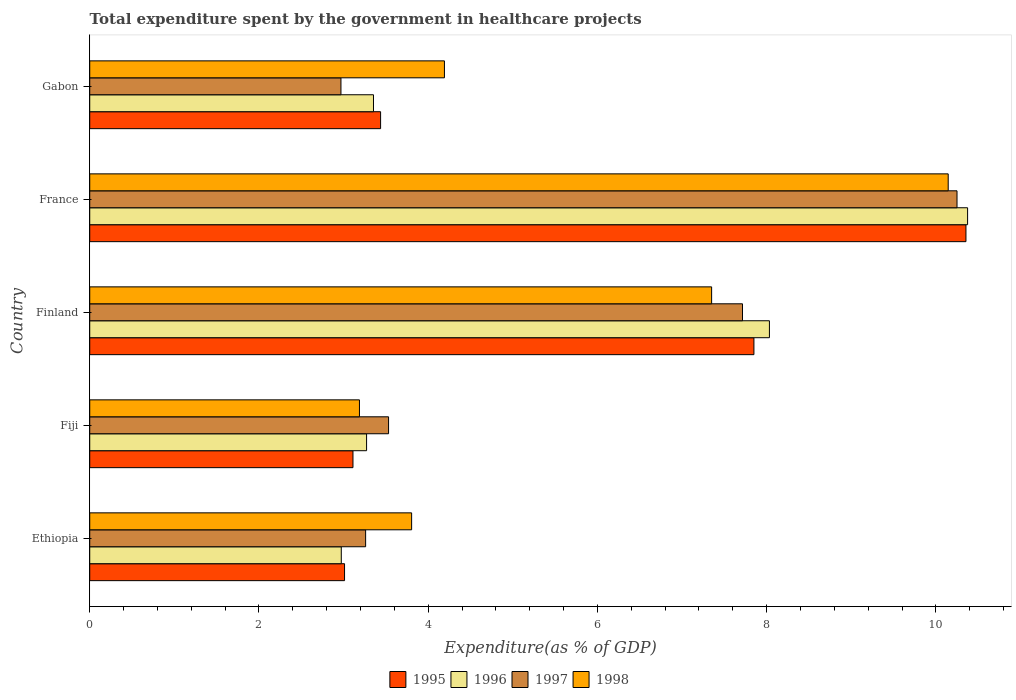How many different coloured bars are there?
Ensure brevity in your answer.  4. How many groups of bars are there?
Your response must be concise. 5. How many bars are there on the 1st tick from the top?
Offer a terse response. 4. How many bars are there on the 2nd tick from the bottom?
Your answer should be very brief. 4. What is the label of the 1st group of bars from the top?
Ensure brevity in your answer.  Gabon. In how many cases, is the number of bars for a given country not equal to the number of legend labels?
Provide a short and direct response. 0. What is the total expenditure spent by the government in healthcare projects in 1995 in Fiji?
Provide a short and direct response. 3.11. Across all countries, what is the maximum total expenditure spent by the government in healthcare projects in 1997?
Give a very brief answer. 10.25. Across all countries, what is the minimum total expenditure spent by the government in healthcare projects in 1995?
Provide a short and direct response. 3.01. In which country was the total expenditure spent by the government in healthcare projects in 1998 maximum?
Your answer should be very brief. France. In which country was the total expenditure spent by the government in healthcare projects in 1998 minimum?
Your answer should be compact. Fiji. What is the total total expenditure spent by the government in healthcare projects in 1998 in the graph?
Provide a short and direct response. 28.68. What is the difference between the total expenditure spent by the government in healthcare projects in 1998 in Finland and that in France?
Make the answer very short. -2.8. What is the difference between the total expenditure spent by the government in healthcare projects in 1997 in France and the total expenditure spent by the government in healthcare projects in 1998 in Finland?
Provide a short and direct response. 2.9. What is the average total expenditure spent by the government in healthcare projects in 1995 per country?
Make the answer very short. 5.55. What is the difference between the total expenditure spent by the government in healthcare projects in 1995 and total expenditure spent by the government in healthcare projects in 1997 in Finland?
Give a very brief answer. 0.14. In how many countries, is the total expenditure spent by the government in healthcare projects in 1997 greater than 6.4 %?
Give a very brief answer. 2. What is the ratio of the total expenditure spent by the government in healthcare projects in 1998 in Finland to that in Gabon?
Keep it short and to the point. 1.75. Is the total expenditure spent by the government in healthcare projects in 1997 in Ethiopia less than that in Fiji?
Keep it short and to the point. Yes. What is the difference between the highest and the second highest total expenditure spent by the government in healthcare projects in 1998?
Keep it short and to the point. 2.8. What is the difference between the highest and the lowest total expenditure spent by the government in healthcare projects in 1998?
Your answer should be very brief. 6.96. What does the 4th bar from the bottom in Gabon represents?
Provide a succinct answer. 1998. How many bars are there?
Provide a succinct answer. 20. Are all the bars in the graph horizontal?
Keep it short and to the point. Yes. Are the values on the major ticks of X-axis written in scientific E-notation?
Keep it short and to the point. No. Where does the legend appear in the graph?
Your answer should be compact. Bottom center. What is the title of the graph?
Your answer should be very brief. Total expenditure spent by the government in healthcare projects. Does "1984" appear as one of the legend labels in the graph?
Keep it short and to the point. No. What is the label or title of the X-axis?
Provide a short and direct response. Expenditure(as % of GDP). What is the Expenditure(as % of GDP) of 1995 in Ethiopia?
Keep it short and to the point. 3.01. What is the Expenditure(as % of GDP) in 1996 in Ethiopia?
Your response must be concise. 2.97. What is the Expenditure(as % of GDP) in 1997 in Ethiopia?
Ensure brevity in your answer.  3.26. What is the Expenditure(as % of GDP) of 1998 in Ethiopia?
Your answer should be very brief. 3.8. What is the Expenditure(as % of GDP) of 1995 in Fiji?
Offer a very short reply. 3.11. What is the Expenditure(as % of GDP) of 1996 in Fiji?
Provide a succinct answer. 3.27. What is the Expenditure(as % of GDP) of 1997 in Fiji?
Ensure brevity in your answer.  3.53. What is the Expenditure(as % of GDP) of 1998 in Fiji?
Make the answer very short. 3.19. What is the Expenditure(as % of GDP) in 1995 in Finland?
Your response must be concise. 7.85. What is the Expenditure(as % of GDP) of 1996 in Finland?
Your response must be concise. 8.03. What is the Expenditure(as % of GDP) of 1997 in Finland?
Make the answer very short. 7.71. What is the Expenditure(as % of GDP) of 1998 in Finland?
Keep it short and to the point. 7.35. What is the Expenditure(as % of GDP) in 1995 in France?
Ensure brevity in your answer.  10.36. What is the Expenditure(as % of GDP) of 1996 in France?
Give a very brief answer. 10.38. What is the Expenditure(as % of GDP) in 1997 in France?
Your answer should be compact. 10.25. What is the Expenditure(as % of GDP) of 1998 in France?
Your answer should be very brief. 10.15. What is the Expenditure(as % of GDP) in 1995 in Gabon?
Provide a short and direct response. 3.44. What is the Expenditure(as % of GDP) of 1996 in Gabon?
Your answer should be compact. 3.35. What is the Expenditure(as % of GDP) in 1997 in Gabon?
Provide a short and direct response. 2.97. What is the Expenditure(as % of GDP) of 1998 in Gabon?
Offer a terse response. 4.19. Across all countries, what is the maximum Expenditure(as % of GDP) in 1995?
Your answer should be compact. 10.36. Across all countries, what is the maximum Expenditure(as % of GDP) in 1996?
Your answer should be very brief. 10.38. Across all countries, what is the maximum Expenditure(as % of GDP) in 1997?
Offer a terse response. 10.25. Across all countries, what is the maximum Expenditure(as % of GDP) in 1998?
Your answer should be very brief. 10.15. Across all countries, what is the minimum Expenditure(as % of GDP) in 1995?
Make the answer very short. 3.01. Across all countries, what is the minimum Expenditure(as % of GDP) in 1996?
Your answer should be compact. 2.97. Across all countries, what is the minimum Expenditure(as % of GDP) of 1997?
Offer a terse response. 2.97. Across all countries, what is the minimum Expenditure(as % of GDP) in 1998?
Provide a short and direct response. 3.19. What is the total Expenditure(as % of GDP) of 1995 in the graph?
Your response must be concise. 27.77. What is the total Expenditure(as % of GDP) in 1996 in the graph?
Provide a short and direct response. 28.01. What is the total Expenditure(as % of GDP) in 1997 in the graph?
Make the answer very short. 27.73. What is the total Expenditure(as % of GDP) of 1998 in the graph?
Offer a terse response. 28.68. What is the difference between the Expenditure(as % of GDP) in 1995 in Ethiopia and that in Fiji?
Provide a short and direct response. -0.1. What is the difference between the Expenditure(as % of GDP) of 1996 in Ethiopia and that in Fiji?
Offer a very short reply. -0.3. What is the difference between the Expenditure(as % of GDP) of 1997 in Ethiopia and that in Fiji?
Your answer should be compact. -0.27. What is the difference between the Expenditure(as % of GDP) of 1998 in Ethiopia and that in Fiji?
Ensure brevity in your answer.  0.62. What is the difference between the Expenditure(as % of GDP) of 1995 in Ethiopia and that in Finland?
Your answer should be very brief. -4.84. What is the difference between the Expenditure(as % of GDP) in 1996 in Ethiopia and that in Finland?
Your answer should be very brief. -5.06. What is the difference between the Expenditure(as % of GDP) of 1997 in Ethiopia and that in Finland?
Ensure brevity in your answer.  -4.45. What is the difference between the Expenditure(as % of GDP) of 1998 in Ethiopia and that in Finland?
Provide a succinct answer. -3.55. What is the difference between the Expenditure(as % of GDP) of 1995 in Ethiopia and that in France?
Your answer should be very brief. -7.34. What is the difference between the Expenditure(as % of GDP) of 1996 in Ethiopia and that in France?
Provide a short and direct response. -7.4. What is the difference between the Expenditure(as % of GDP) of 1997 in Ethiopia and that in France?
Your answer should be compact. -6.99. What is the difference between the Expenditure(as % of GDP) in 1998 in Ethiopia and that in France?
Ensure brevity in your answer.  -6.34. What is the difference between the Expenditure(as % of GDP) in 1995 in Ethiopia and that in Gabon?
Your response must be concise. -0.43. What is the difference between the Expenditure(as % of GDP) in 1996 in Ethiopia and that in Gabon?
Make the answer very short. -0.38. What is the difference between the Expenditure(as % of GDP) in 1997 in Ethiopia and that in Gabon?
Offer a very short reply. 0.29. What is the difference between the Expenditure(as % of GDP) in 1998 in Ethiopia and that in Gabon?
Your answer should be very brief. -0.39. What is the difference between the Expenditure(as % of GDP) of 1995 in Fiji and that in Finland?
Your response must be concise. -4.74. What is the difference between the Expenditure(as % of GDP) in 1996 in Fiji and that in Finland?
Keep it short and to the point. -4.76. What is the difference between the Expenditure(as % of GDP) of 1997 in Fiji and that in Finland?
Provide a succinct answer. -4.18. What is the difference between the Expenditure(as % of GDP) of 1998 in Fiji and that in Finland?
Your answer should be very brief. -4.16. What is the difference between the Expenditure(as % of GDP) in 1995 in Fiji and that in France?
Provide a short and direct response. -7.24. What is the difference between the Expenditure(as % of GDP) in 1996 in Fiji and that in France?
Your answer should be very brief. -7.1. What is the difference between the Expenditure(as % of GDP) of 1997 in Fiji and that in France?
Offer a terse response. -6.72. What is the difference between the Expenditure(as % of GDP) of 1998 in Fiji and that in France?
Make the answer very short. -6.96. What is the difference between the Expenditure(as % of GDP) in 1995 in Fiji and that in Gabon?
Provide a short and direct response. -0.33. What is the difference between the Expenditure(as % of GDP) of 1996 in Fiji and that in Gabon?
Keep it short and to the point. -0.08. What is the difference between the Expenditure(as % of GDP) in 1997 in Fiji and that in Gabon?
Offer a very short reply. 0.56. What is the difference between the Expenditure(as % of GDP) of 1998 in Fiji and that in Gabon?
Make the answer very short. -1. What is the difference between the Expenditure(as % of GDP) of 1995 in Finland and that in France?
Provide a short and direct response. -2.51. What is the difference between the Expenditure(as % of GDP) in 1996 in Finland and that in France?
Make the answer very short. -2.34. What is the difference between the Expenditure(as % of GDP) in 1997 in Finland and that in France?
Your response must be concise. -2.54. What is the difference between the Expenditure(as % of GDP) of 1998 in Finland and that in France?
Your response must be concise. -2.8. What is the difference between the Expenditure(as % of GDP) of 1995 in Finland and that in Gabon?
Offer a very short reply. 4.41. What is the difference between the Expenditure(as % of GDP) in 1996 in Finland and that in Gabon?
Offer a terse response. 4.68. What is the difference between the Expenditure(as % of GDP) of 1997 in Finland and that in Gabon?
Provide a short and direct response. 4.75. What is the difference between the Expenditure(as % of GDP) in 1998 in Finland and that in Gabon?
Provide a short and direct response. 3.16. What is the difference between the Expenditure(as % of GDP) of 1995 in France and that in Gabon?
Make the answer very short. 6.92. What is the difference between the Expenditure(as % of GDP) in 1996 in France and that in Gabon?
Ensure brevity in your answer.  7.02. What is the difference between the Expenditure(as % of GDP) of 1997 in France and that in Gabon?
Your answer should be very brief. 7.28. What is the difference between the Expenditure(as % of GDP) of 1998 in France and that in Gabon?
Make the answer very short. 5.95. What is the difference between the Expenditure(as % of GDP) in 1995 in Ethiopia and the Expenditure(as % of GDP) in 1996 in Fiji?
Ensure brevity in your answer.  -0.26. What is the difference between the Expenditure(as % of GDP) of 1995 in Ethiopia and the Expenditure(as % of GDP) of 1997 in Fiji?
Provide a succinct answer. -0.52. What is the difference between the Expenditure(as % of GDP) of 1995 in Ethiopia and the Expenditure(as % of GDP) of 1998 in Fiji?
Give a very brief answer. -0.18. What is the difference between the Expenditure(as % of GDP) of 1996 in Ethiopia and the Expenditure(as % of GDP) of 1997 in Fiji?
Make the answer very short. -0.56. What is the difference between the Expenditure(as % of GDP) in 1996 in Ethiopia and the Expenditure(as % of GDP) in 1998 in Fiji?
Make the answer very short. -0.21. What is the difference between the Expenditure(as % of GDP) in 1997 in Ethiopia and the Expenditure(as % of GDP) in 1998 in Fiji?
Give a very brief answer. 0.07. What is the difference between the Expenditure(as % of GDP) in 1995 in Ethiopia and the Expenditure(as % of GDP) in 1996 in Finland?
Offer a very short reply. -5.02. What is the difference between the Expenditure(as % of GDP) in 1995 in Ethiopia and the Expenditure(as % of GDP) in 1997 in Finland?
Keep it short and to the point. -4.7. What is the difference between the Expenditure(as % of GDP) in 1995 in Ethiopia and the Expenditure(as % of GDP) in 1998 in Finland?
Provide a short and direct response. -4.34. What is the difference between the Expenditure(as % of GDP) of 1996 in Ethiopia and the Expenditure(as % of GDP) of 1997 in Finland?
Provide a short and direct response. -4.74. What is the difference between the Expenditure(as % of GDP) of 1996 in Ethiopia and the Expenditure(as % of GDP) of 1998 in Finland?
Ensure brevity in your answer.  -4.38. What is the difference between the Expenditure(as % of GDP) of 1997 in Ethiopia and the Expenditure(as % of GDP) of 1998 in Finland?
Ensure brevity in your answer.  -4.09. What is the difference between the Expenditure(as % of GDP) in 1995 in Ethiopia and the Expenditure(as % of GDP) in 1996 in France?
Offer a very short reply. -7.36. What is the difference between the Expenditure(as % of GDP) of 1995 in Ethiopia and the Expenditure(as % of GDP) of 1997 in France?
Your answer should be very brief. -7.24. What is the difference between the Expenditure(as % of GDP) of 1995 in Ethiopia and the Expenditure(as % of GDP) of 1998 in France?
Keep it short and to the point. -7.13. What is the difference between the Expenditure(as % of GDP) in 1996 in Ethiopia and the Expenditure(as % of GDP) in 1997 in France?
Offer a very short reply. -7.28. What is the difference between the Expenditure(as % of GDP) in 1996 in Ethiopia and the Expenditure(as % of GDP) in 1998 in France?
Keep it short and to the point. -7.17. What is the difference between the Expenditure(as % of GDP) in 1997 in Ethiopia and the Expenditure(as % of GDP) in 1998 in France?
Keep it short and to the point. -6.89. What is the difference between the Expenditure(as % of GDP) of 1995 in Ethiopia and the Expenditure(as % of GDP) of 1996 in Gabon?
Your response must be concise. -0.34. What is the difference between the Expenditure(as % of GDP) in 1995 in Ethiopia and the Expenditure(as % of GDP) in 1997 in Gabon?
Ensure brevity in your answer.  0.04. What is the difference between the Expenditure(as % of GDP) of 1995 in Ethiopia and the Expenditure(as % of GDP) of 1998 in Gabon?
Provide a succinct answer. -1.18. What is the difference between the Expenditure(as % of GDP) in 1996 in Ethiopia and the Expenditure(as % of GDP) in 1997 in Gabon?
Keep it short and to the point. 0. What is the difference between the Expenditure(as % of GDP) in 1996 in Ethiopia and the Expenditure(as % of GDP) in 1998 in Gabon?
Ensure brevity in your answer.  -1.22. What is the difference between the Expenditure(as % of GDP) in 1997 in Ethiopia and the Expenditure(as % of GDP) in 1998 in Gabon?
Your answer should be very brief. -0.93. What is the difference between the Expenditure(as % of GDP) in 1995 in Fiji and the Expenditure(as % of GDP) in 1996 in Finland?
Make the answer very short. -4.92. What is the difference between the Expenditure(as % of GDP) of 1995 in Fiji and the Expenditure(as % of GDP) of 1997 in Finland?
Provide a succinct answer. -4.6. What is the difference between the Expenditure(as % of GDP) in 1995 in Fiji and the Expenditure(as % of GDP) in 1998 in Finland?
Offer a very short reply. -4.24. What is the difference between the Expenditure(as % of GDP) of 1996 in Fiji and the Expenditure(as % of GDP) of 1997 in Finland?
Provide a short and direct response. -4.44. What is the difference between the Expenditure(as % of GDP) in 1996 in Fiji and the Expenditure(as % of GDP) in 1998 in Finland?
Provide a short and direct response. -4.08. What is the difference between the Expenditure(as % of GDP) of 1997 in Fiji and the Expenditure(as % of GDP) of 1998 in Finland?
Your answer should be very brief. -3.82. What is the difference between the Expenditure(as % of GDP) of 1995 in Fiji and the Expenditure(as % of GDP) of 1996 in France?
Give a very brief answer. -7.26. What is the difference between the Expenditure(as % of GDP) in 1995 in Fiji and the Expenditure(as % of GDP) in 1997 in France?
Offer a terse response. -7.14. What is the difference between the Expenditure(as % of GDP) in 1995 in Fiji and the Expenditure(as % of GDP) in 1998 in France?
Offer a very short reply. -7.04. What is the difference between the Expenditure(as % of GDP) of 1996 in Fiji and the Expenditure(as % of GDP) of 1997 in France?
Offer a terse response. -6.98. What is the difference between the Expenditure(as % of GDP) in 1996 in Fiji and the Expenditure(as % of GDP) in 1998 in France?
Keep it short and to the point. -6.87. What is the difference between the Expenditure(as % of GDP) of 1997 in Fiji and the Expenditure(as % of GDP) of 1998 in France?
Your answer should be compact. -6.61. What is the difference between the Expenditure(as % of GDP) in 1995 in Fiji and the Expenditure(as % of GDP) in 1996 in Gabon?
Ensure brevity in your answer.  -0.24. What is the difference between the Expenditure(as % of GDP) in 1995 in Fiji and the Expenditure(as % of GDP) in 1997 in Gabon?
Keep it short and to the point. 0.14. What is the difference between the Expenditure(as % of GDP) of 1995 in Fiji and the Expenditure(as % of GDP) of 1998 in Gabon?
Provide a succinct answer. -1.08. What is the difference between the Expenditure(as % of GDP) of 1996 in Fiji and the Expenditure(as % of GDP) of 1997 in Gabon?
Make the answer very short. 0.3. What is the difference between the Expenditure(as % of GDP) of 1996 in Fiji and the Expenditure(as % of GDP) of 1998 in Gabon?
Ensure brevity in your answer.  -0.92. What is the difference between the Expenditure(as % of GDP) of 1997 in Fiji and the Expenditure(as % of GDP) of 1998 in Gabon?
Your response must be concise. -0.66. What is the difference between the Expenditure(as % of GDP) of 1995 in Finland and the Expenditure(as % of GDP) of 1996 in France?
Offer a very short reply. -2.53. What is the difference between the Expenditure(as % of GDP) of 1995 in Finland and the Expenditure(as % of GDP) of 1997 in France?
Give a very brief answer. -2.4. What is the difference between the Expenditure(as % of GDP) in 1995 in Finland and the Expenditure(as % of GDP) in 1998 in France?
Ensure brevity in your answer.  -2.3. What is the difference between the Expenditure(as % of GDP) of 1996 in Finland and the Expenditure(as % of GDP) of 1997 in France?
Ensure brevity in your answer.  -2.22. What is the difference between the Expenditure(as % of GDP) of 1996 in Finland and the Expenditure(as % of GDP) of 1998 in France?
Provide a short and direct response. -2.11. What is the difference between the Expenditure(as % of GDP) of 1997 in Finland and the Expenditure(as % of GDP) of 1998 in France?
Provide a short and direct response. -2.43. What is the difference between the Expenditure(as % of GDP) in 1995 in Finland and the Expenditure(as % of GDP) in 1996 in Gabon?
Provide a short and direct response. 4.5. What is the difference between the Expenditure(as % of GDP) in 1995 in Finland and the Expenditure(as % of GDP) in 1997 in Gabon?
Your answer should be compact. 4.88. What is the difference between the Expenditure(as % of GDP) of 1995 in Finland and the Expenditure(as % of GDP) of 1998 in Gabon?
Ensure brevity in your answer.  3.66. What is the difference between the Expenditure(as % of GDP) in 1996 in Finland and the Expenditure(as % of GDP) in 1997 in Gabon?
Your response must be concise. 5.06. What is the difference between the Expenditure(as % of GDP) of 1996 in Finland and the Expenditure(as % of GDP) of 1998 in Gabon?
Your response must be concise. 3.84. What is the difference between the Expenditure(as % of GDP) in 1997 in Finland and the Expenditure(as % of GDP) in 1998 in Gabon?
Your response must be concise. 3.52. What is the difference between the Expenditure(as % of GDP) in 1995 in France and the Expenditure(as % of GDP) in 1996 in Gabon?
Keep it short and to the point. 7. What is the difference between the Expenditure(as % of GDP) in 1995 in France and the Expenditure(as % of GDP) in 1997 in Gabon?
Offer a very short reply. 7.39. What is the difference between the Expenditure(as % of GDP) of 1995 in France and the Expenditure(as % of GDP) of 1998 in Gabon?
Offer a terse response. 6.16. What is the difference between the Expenditure(as % of GDP) in 1996 in France and the Expenditure(as % of GDP) in 1997 in Gabon?
Your answer should be very brief. 7.41. What is the difference between the Expenditure(as % of GDP) in 1996 in France and the Expenditure(as % of GDP) in 1998 in Gabon?
Your response must be concise. 6.18. What is the difference between the Expenditure(as % of GDP) of 1997 in France and the Expenditure(as % of GDP) of 1998 in Gabon?
Provide a short and direct response. 6.06. What is the average Expenditure(as % of GDP) in 1995 per country?
Provide a succinct answer. 5.55. What is the average Expenditure(as % of GDP) in 1996 per country?
Make the answer very short. 5.6. What is the average Expenditure(as % of GDP) in 1997 per country?
Your answer should be very brief. 5.55. What is the average Expenditure(as % of GDP) in 1998 per country?
Give a very brief answer. 5.74. What is the difference between the Expenditure(as % of GDP) in 1995 and Expenditure(as % of GDP) in 1996 in Ethiopia?
Your answer should be very brief. 0.04. What is the difference between the Expenditure(as % of GDP) in 1995 and Expenditure(as % of GDP) in 1997 in Ethiopia?
Provide a succinct answer. -0.25. What is the difference between the Expenditure(as % of GDP) in 1995 and Expenditure(as % of GDP) in 1998 in Ethiopia?
Make the answer very short. -0.79. What is the difference between the Expenditure(as % of GDP) of 1996 and Expenditure(as % of GDP) of 1997 in Ethiopia?
Your answer should be very brief. -0.29. What is the difference between the Expenditure(as % of GDP) in 1996 and Expenditure(as % of GDP) in 1998 in Ethiopia?
Your answer should be compact. -0.83. What is the difference between the Expenditure(as % of GDP) of 1997 and Expenditure(as % of GDP) of 1998 in Ethiopia?
Ensure brevity in your answer.  -0.54. What is the difference between the Expenditure(as % of GDP) in 1995 and Expenditure(as % of GDP) in 1996 in Fiji?
Give a very brief answer. -0.16. What is the difference between the Expenditure(as % of GDP) in 1995 and Expenditure(as % of GDP) in 1997 in Fiji?
Offer a very short reply. -0.42. What is the difference between the Expenditure(as % of GDP) in 1995 and Expenditure(as % of GDP) in 1998 in Fiji?
Your answer should be very brief. -0.08. What is the difference between the Expenditure(as % of GDP) in 1996 and Expenditure(as % of GDP) in 1997 in Fiji?
Give a very brief answer. -0.26. What is the difference between the Expenditure(as % of GDP) in 1996 and Expenditure(as % of GDP) in 1998 in Fiji?
Give a very brief answer. 0.08. What is the difference between the Expenditure(as % of GDP) in 1997 and Expenditure(as % of GDP) in 1998 in Fiji?
Your response must be concise. 0.34. What is the difference between the Expenditure(as % of GDP) in 1995 and Expenditure(as % of GDP) in 1996 in Finland?
Your answer should be very brief. -0.18. What is the difference between the Expenditure(as % of GDP) of 1995 and Expenditure(as % of GDP) of 1997 in Finland?
Ensure brevity in your answer.  0.14. What is the difference between the Expenditure(as % of GDP) of 1995 and Expenditure(as % of GDP) of 1998 in Finland?
Your response must be concise. 0.5. What is the difference between the Expenditure(as % of GDP) in 1996 and Expenditure(as % of GDP) in 1997 in Finland?
Your response must be concise. 0.32. What is the difference between the Expenditure(as % of GDP) in 1996 and Expenditure(as % of GDP) in 1998 in Finland?
Your response must be concise. 0.68. What is the difference between the Expenditure(as % of GDP) in 1997 and Expenditure(as % of GDP) in 1998 in Finland?
Keep it short and to the point. 0.36. What is the difference between the Expenditure(as % of GDP) of 1995 and Expenditure(as % of GDP) of 1996 in France?
Provide a succinct answer. -0.02. What is the difference between the Expenditure(as % of GDP) in 1995 and Expenditure(as % of GDP) in 1997 in France?
Your answer should be very brief. 0.11. What is the difference between the Expenditure(as % of GDP) in 1995 and Expenditure(as % of GDP) in 1998 in France?
Your response must be concise. 0.21. What is the difference between the Expenditure(as % of GDP) in 1996 and Expenditure(as % of GDP) in 1998 in France?
Offer a very short reply. 0.23. What is the difference between the Expenditure(as % of GDP) in 1997 and Expenditure(as % of GDP) in 1998 in France?
Make the answer very short. 0.1. What is the difference between the Expenditure(as % of GDP) of 1995 and Expenditure(as % of GDP) of 1996 in Gabon?
Provide a short and direct response. 0.08. What is the difference between the Expenditure(as % of GDP) of 1995 and Expenditure(as % of GDP) of 1997 in Gabon?
Make the answer very short. 0.47. What is the difference between the Expenditure(as % of GDP) of 1995 and Expenditure(as % of GDP) of 1998 in Gabon?
Your answer should be very brief. -0.75. What is the difference between the Expenditure(as % of GDP) in 1996 and Expenditure(as % of GDP) in 1997 in Gabon?
Give a very brief answer. 0.38. What is the difference between the Expenditure(as % of GDP) in 1996 and Expenditure(as % of GDP) in 1998 in Gabon?
Your answer should be very brief. -0.84. What is the difference between the Expenditure(as % of GDP) of 1997 and Expenditure(as % of GDP) of 1998 in Gabon?
Keep it short and to the point. -1.22. What is the ratio of the Expenditure(as % of GDP) of 1996 in Ethiopia to that in Fiji?
Provide a succinct answer. 0.91. What is the ratio of the Expenditure(as % of GDP) of 1997 in Ethiopia to that in Fiji?
Your response must be concise. 0.92. What is the ratio of the Expenditure(as % of GDP) in 1998 in Ethiopia to that in Fiji?
Offer a very short reply. 1.19. What is the ratio of the Expenditure(as % of GDP) of 1995 in Ethiopia to that in Finland?
Your answer should be very brief. 0.38. What is the ratio of the Expenditure(as % of GDP) of 1996 in Ethiopia to that in Finland?
Your answer should be very brief. 0.37. What is the ratio of the Expenditure(as % of GDP) of 1997 in Ethiopia to that in Finland?
Offer a very short reply. 0.42. What is the ratio of the Expenditure(as % of GDP) of 1998 in Ethiopia to that in Finland?
Keep it short and to the point. 0.52. What is the ratio of the Expenditure(as % of GDP) in 1995 in Ethiopia to that in France?
Make the answer very short. 0.29. What is the ratio of the Expenditure(as % of GDP) of 1996 in Ethiopia to that in France?
Offer a very short reply. 0.29. What is the ratio of the Expenditure(as % of GDP) of 1997 in Ethiopia to that in France?
Make the answer very short. 0.32. What is the ratio of the Expenditure(as % of GDP) of 1998 in Ethiopia to that in France?
Your answer should be very brief. 0.38. What is the ratio of the Expenditure(as % of GDP) of 1995 in Ethiopia to that in Gabon?
Offer a very short reply. 0.88. What is the ratio of the Expenditure(as % of GDP) of 1996 in Ethiopia to that in Gabon?
Provide a short and direct response. 0.89. What is the ratio of the Expenditure(as % of GDP) of 1997 in Ethiopia to that in Gabon?
Give a very brief answer. 1.1. What is the ratio of the Expenditure(as % of GDP) of 1998 in Ethiopia to that in Gabon?
Offer a very short reply. 0.91. What is the ratio of the Expenditure(as % of GDP) of 1995 in Fiji to that in Finland?
Keep it short and to the point. 0.4. What is the ratio of the Expenditure(as % of GDP) of 1996 in Fiji to that in Finland?
Give a very brief answer. 0.41. What is the ratio of the Expenditure(as % of GDP) of 1997 in Fiji to that in Finland?
Offer a terse response. 0.46. What is the ratio of the Expenditure(as % of GDP) in 1998 in Fiji to that in Finland?
Provide a succinct answer. 0.43. What is the ratio of the Expenditure(as % of GDP) in 1995 in Fiji to that in France?
Offer a terse response. 0.3. What is the ratio of the Expenditure(as % of GDP) of 1996 in Fiji to that in France?
Provide a short and direct response. 0.32. What is the ratio of the Expenditure(as % of GDP) of 1997 in Fiji to that in France?
Provide a short and direct response. 0.34. What is the ratio of the Expenditure(as % of GDP) in 1998 in Fiji to that in France?
Your answer should be very brief. 0.31. What is the ratio of the Expenditure(as % of GDP) of 1995 in Fiji to that in Gabon?
Ensure brevity in your answer.  0.91. What is the ratio of the Expenditure(as % of GDP) in 1996 in Fiji to that in Gabon?
Keep it short and to the point. 0.98. What is the ratio of the Expenditure(as % of GDP) of 1997 in Fiji to that in Gabon?
Keep it short and to the point. 1.19. What is the ratio of the Expenditure(as % of GDP) in 1998 in Fiji to that in Gabon?
Provide a short and direct response. 0.76. What is the ratio of the Expenditure(as % of GDP) of 1995 in Finland to that in France?
Keep it short and to the point. 0.76. What is the ratio of the Expenditure(as % of GDP) of 1996 in Finland to that in France?
Ensure brevity in your answer.  0.77. What is the ratio of the Expenditure(as % of GDP) of 1997 in Finland to that in France?
Make the answer very short. 0.75. What is the ratio of the Expenditure(as % of GDP) of 1998 in Finland to that in France?
Give a very brief answer. 0.72. What is the ratio of the Expenditure(as % of GDP) in 1995 in Finland to that in Gabon?
Offer a terse response. 2.28. What is the ratio of the Expenditure(as % of GDP) in 1996 in Finland to that in Gabon?
Offer a terse response. 2.4. What is the ratio of the Expenditure(as % of GDP) of 1997 in Finland to that in Gabon?
Offer a terse response. 2.6. What is the ratio of the Expenditure(as % of GDP) of 1998 in Finland to that in Gabon?
Ensure brevity in your answer.  1.75. What is the ratio of the Expenditure(as % of GDP) of 1995 in France to that in Gabon?
Your answer should be very brief. 3.01. What is the ratio of the Expenditure(as % of GDP) of 1996 in France to that in Gabon?
Ensure brevity in your answer.  3.09. What is the ratio of the Expenditure(as % of GDP) in 1997 in France to that in Gabon?
Your answer should be compact. 3.45. What is the ratio of the Expenditure(as % of GDP) in 1998 in France to that in Gabon?
Ensure brevity in your answer.  2.42. What is the difference between the highest and the second highest Expenditure(as % of GDP) in 1995?
Your answer should be very brief. 2.51. What is the difference between the highest and the second highest Expenditure(as % of GDP) of 1996?
Provide a short and direct response. 2.34. What is the difference between the highest and the second highest Expenditure(as % of GDP) of 1997?
Offer a terse response. 2.54. What is the difference between the highest and the second highest Expenditure(as % of GDP) of 1998?
Your response must be concise. 2.8. What is the difference between the highest and the lowest Expenditure(as % of GDP) of 1995?
Provide a succinct answer. 7.34. What is the difference between the highest and the lowest Expenditure(as % of GDP) in 1996?
Provide a short and direct response. 7.4. What is the difference between the highest and the lowest Expenditure(as % of GDP) in 1997?
Offer a very short reply. 7.28. What is the difference between the highest and the lowest Expenditure(as % of GDP) of 1998?
Make the answer very short. 6.96. 